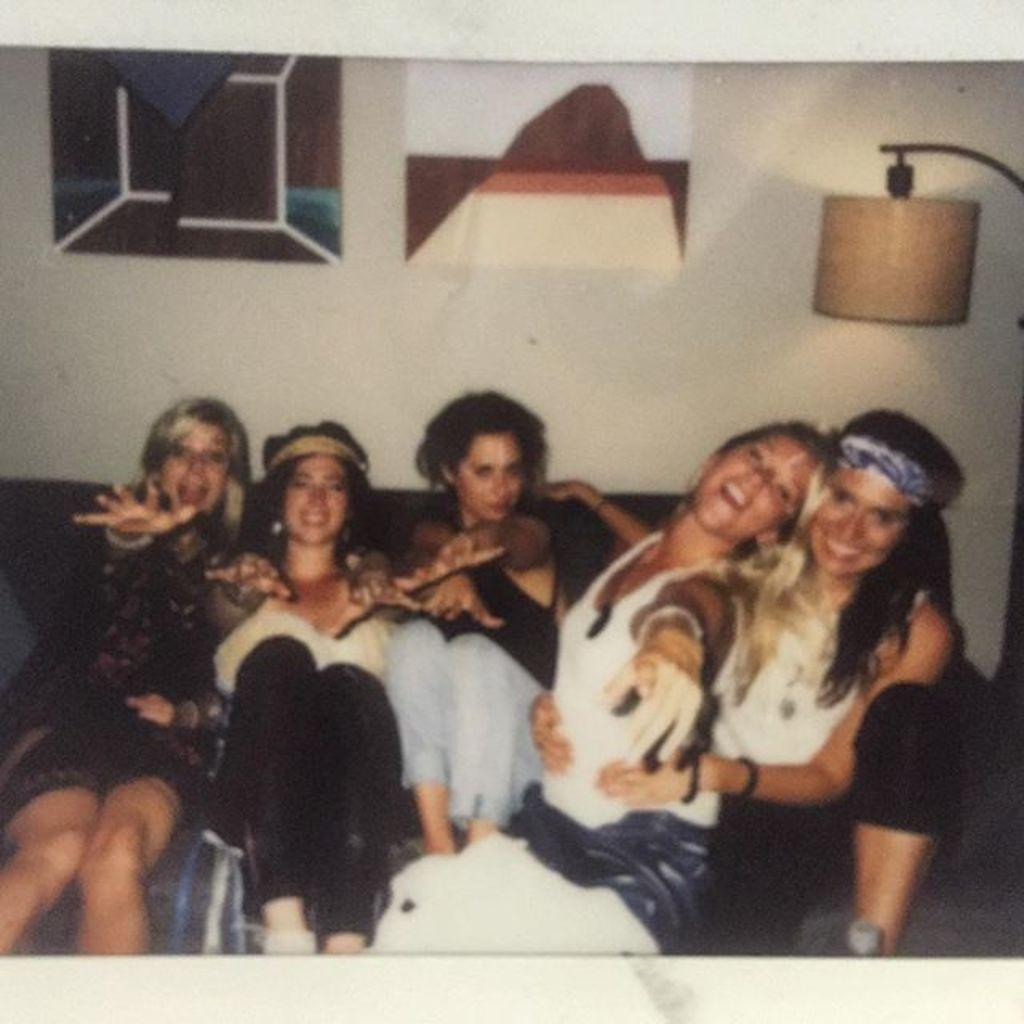How many girls are sitting on the sofa in the image? There are five girls sitting on the sofa in the image. What can be seen on the right side of the image? There is a lamp on the right side of the image. What is present on the wall at the top of the image? There are frames on the wall at the top of the image. What type of meal is being prepared on the shoe in the image? There is no shoe or meal preparation present in the image. 